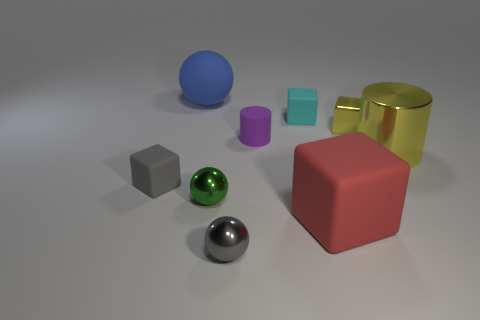Are there any small gray metal things of the same shape as the large blue thing?
Keep it short and to the point. Yes. How many blue objects are big spheres or big rubber cubes?
Keep it short and to the point. 1. Are there any red objects that have the same size as the cyan object?
Offer a terse response. No. How many gray rubber blocks are there?
Offer a terse response. 1. How many tiny things are either yellow metal cylinders or purple shiny blocks?
Your response must be concise. 0. There is a cube that is in front of the cube on the left side of the metal ball in front of the red cube; what color is it?
Provide a succinct answer. Red. What number of other objects are there of the same color as the large ball?
Your response must be concise. 0. How many metal things are gray objects or big cyan cylinders?
Give a very brief answer. 1. Does the tiny shiny thing behind the gray block have the same color as the cylinder that is in front of the small cylinder?
Offer a very short reply. Yes. There is a yellow thing that is the same shape as the gray rubber thing; what is its size?
Your answer should be very brief. Small. 